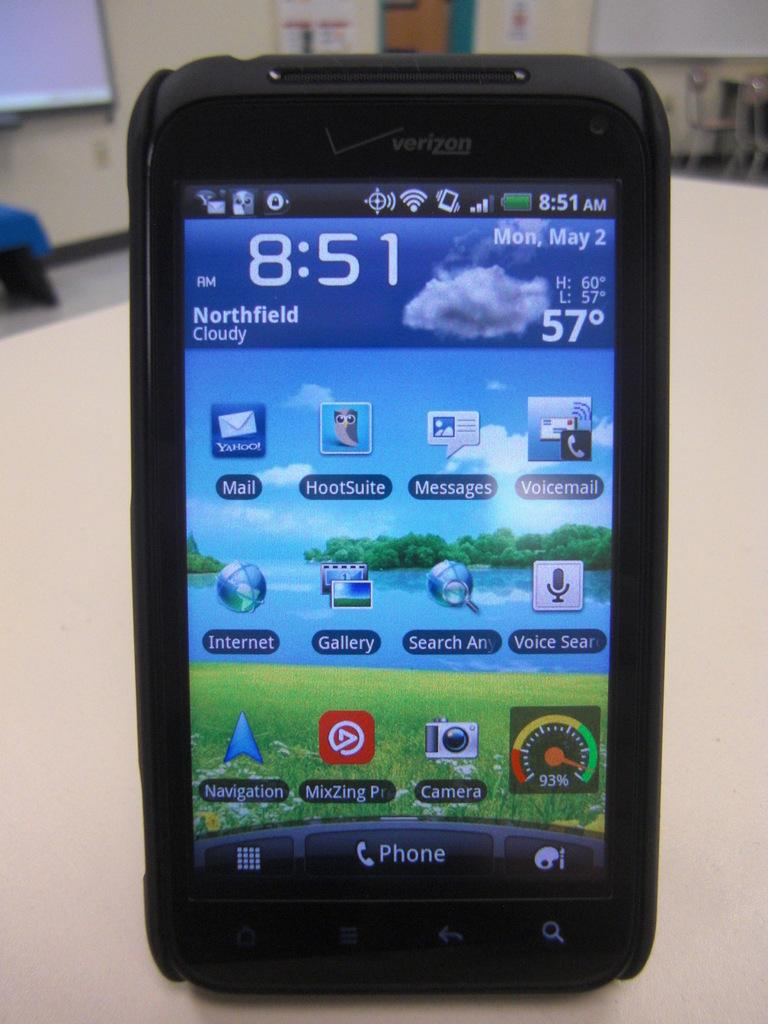<image>
Describe the image concisely. A cellphone screen that says the time of 8:51 